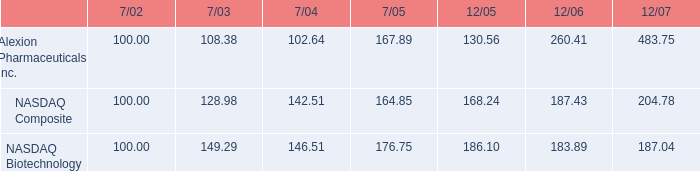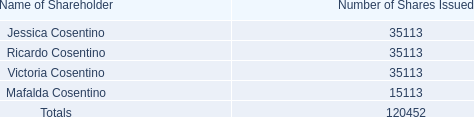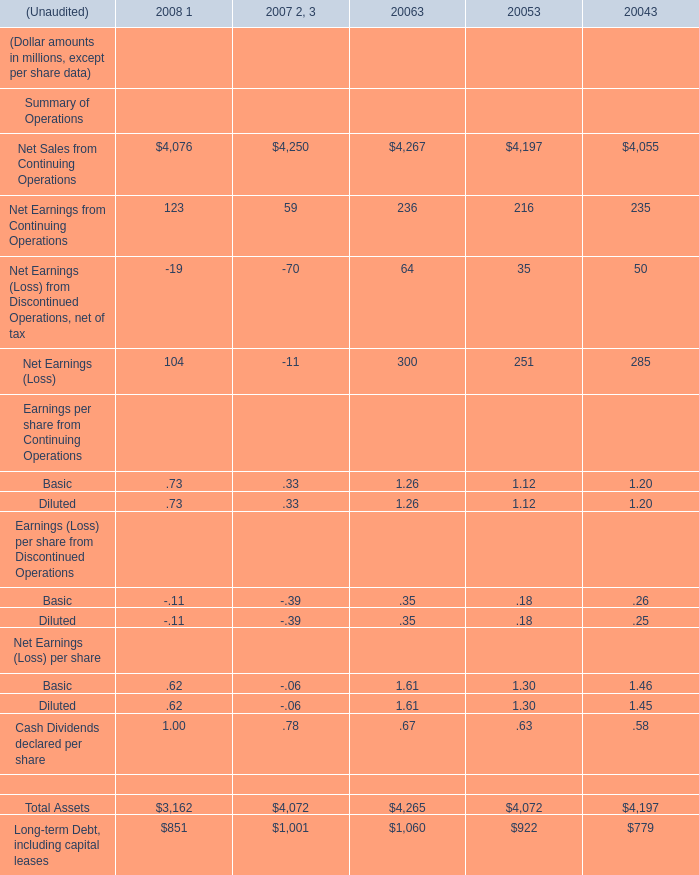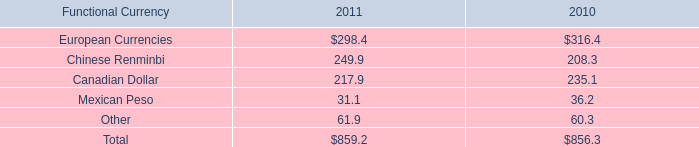What is the sum of Net Sales from Continuing Operations of 2007 2, 3 [EMPTY].1, and Mafalda Cosentino of Number of Shares Issued ? 
Computations: (4197.0 + 15113.0)
Answer: 19310.0. 